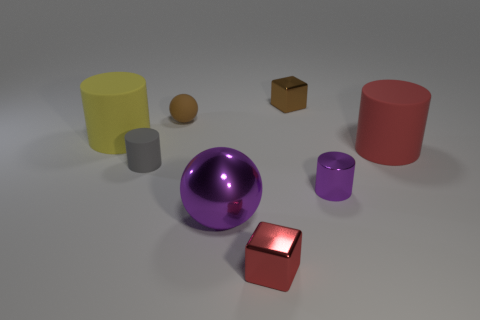There is a cylinder that is the same color as the metal ball; what material is it?
Offer a terse response. Metal. What number of small things are brown matte balls or gray matte blocks?
Your answer should be very brief. 1. Is there anything else of the same color as the small matte cylinder?
Give a very brief answer. No. Does the purple shiny object that is in front of the purple metal cylinder have the same size as the tiny brown cube?
Keep it short and to the point. No. What is the color of the shiny cube that is behind the tiny block that is in front of the purple object on the left side of the purple metallic cylinder?
Provide a succinct answer. Brown. What is the color of the big metal ball?
Your answer should be very brief. Purple. Is the color of the large shiny sphere the same as the metal cylinder?
Provide a short and direct response. Yes. Is the tiny cube that is behind the tiny brown matte object made of the same material as the purple thing that is to the right of the small red metal block?
Your answer should be very brief. Yes. There is a red thing that is the same shape as the gray matte thing; what is its material?
Your answer should be very brief. Rubber. Is the material of the large ball the same as the tiny gray cylinder?
Keep it short and to the point. No. 